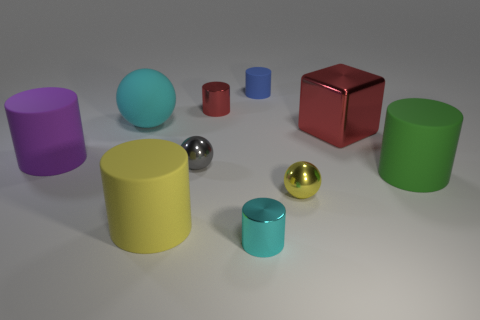Subtract all yellow rubber cylinders. How many cylinders are left? 5 Subtract all gray spheres. How many spheres are left? 2 Subtract 1 cylinders. How many cylinders are left? 5 Subtract all cubes. How many objects are left? 9 Subtract all yellow spheres. Subtract all green blocks. How many spheres are left? 2 Subtract all small rubber blocks. Subtract all yellow spheres. How many objects are left? 9 Add 5 small gray metallic balls. How many small gray metallic balls are left? 6 Add 7 tiny rubber things. How many tiny rubber things exist? 8 Subtract 0 brown cubes. How many objects are left? 10 